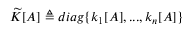<formula> <loc_0><loc_0><loc_500><loc_500>\widetilde { K } [ A ] \triangle q d i a g \{ k _ { 1 } [ A ] , \dots , k _ { n } [ A ] \}</formula> 